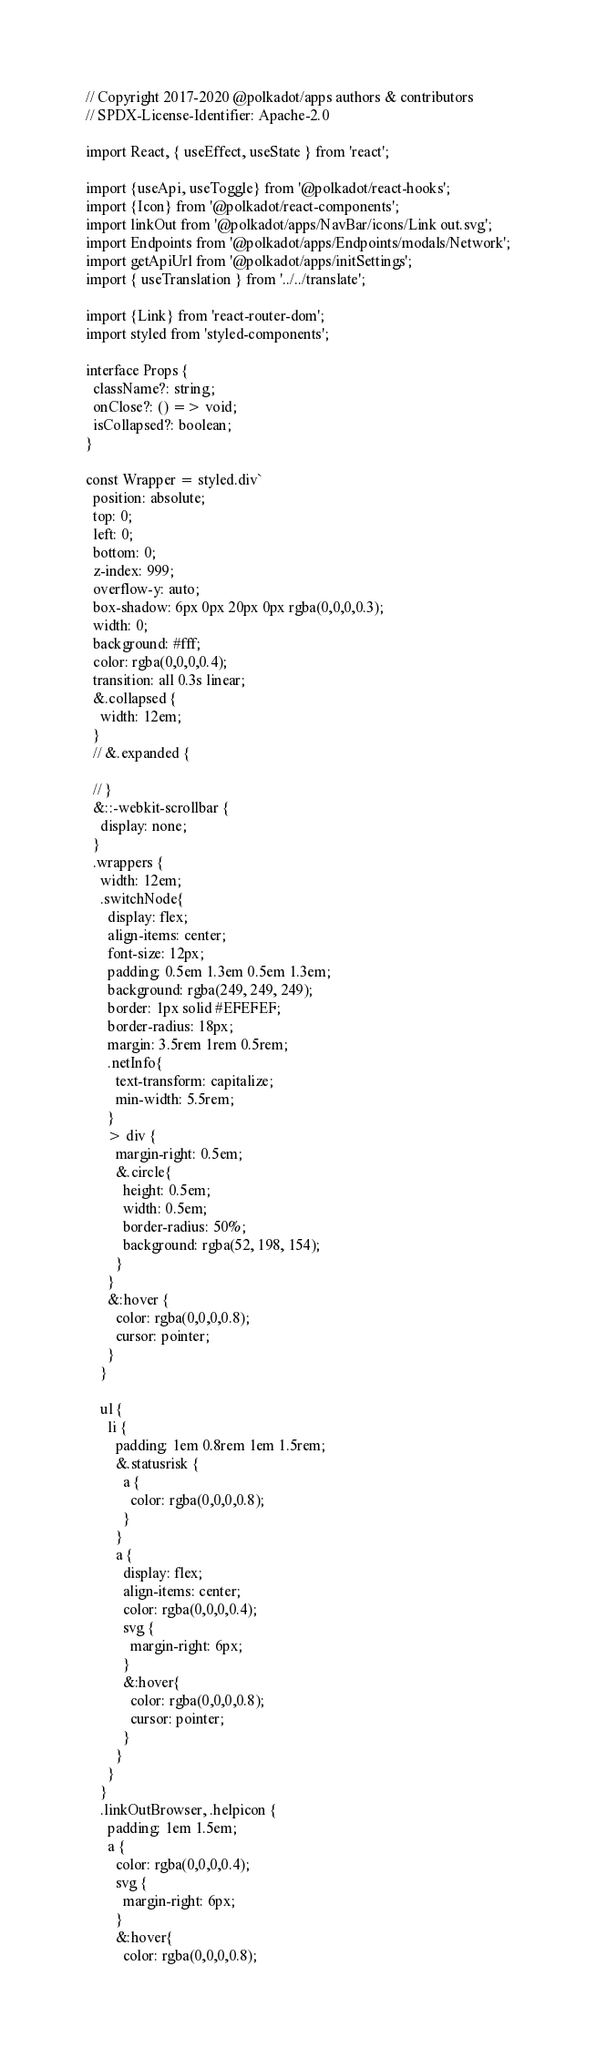Convert code to text. <code><loc_0><loc_0><loc_500><loc_500><_TypeScript_>// Copyright 2017-2020 @polkadot/apps authors & contributors
// SPDX-License-Identifier: Apache-2.0

import React, { useEffect, useState } from 'react';

import {useApi, useToggle} from '@polkadot/react-hooks';
import {Icon} from '@polkadot/react-components';
import linkOut from '@polkadot/apps/NavBar/icons/Link out.svg';
import Endpoints from '@polkadot/apps/Endpoints/modals/Network';
import getApiUrl from '@polkadot/apps/initSettings';
import { useTranslation } from '../../translate';

import {Link} from 'react-router-dom';
import styled from 'styled-components';

interface Props {
  className?: string;
  onClose?: () => void;
  isCollapsed?: boolean;
}

const Wrapper = styled.div`
  position: absolute;
  top: 0;
  left: 0;
  bottom: 0;
  z-index: 999;
  overflow-y: auto;
  box-shadow: 6px 0px 20px 0px rgba(0,0,0,0.3);
  width: 0;
  background: #fff;
  color: rgba(0,0,0,0.4);
  transition: all 0.3s linear;
  &.collapsed {
    width: 12em;
  }
  // &.expanded {

  // }
  &::-webkit-scrollbar {
    display: none;
  }
  .wrappers {
    width: 12em;
    .switchNode{
      display: flex;
      align-items: center;
      font-size: 12px;
      padding: 0.5em 1.3em 0.5em 1.3em;
      background: rgba(249, 249, 249);
      border: 1px solid #EFEFEF;
      border-radius: 18px;
      margin: 3.5rem 1rem 0.5rem;
      .netInfo{
        text-transform: capitalize;
        min-width: 5.5rem;
      }
      > div {
        margin-right: 0.5em;
        &.circle{
          height: 0.5em;
          width: 0.5em;
          border-radius: 50%;
          background: rgba(52, 198, 154);
        }
      }
      &:hover {
        color: rgba(0,0,0,0.8);
        cursor: pointer;
      }
    }

    ul {
      li {
        padding: 1em 0.8rem 1em 1.5rem;
        &.statusrisk {
          a {
            color: rgba(0,0,0,0.8);
          }
        }
        a {
          display: flex;
          align-items: center;
          color: rgba(0,0,0,0.4);
          svg {
            margin-right: 6px;
          }
          &:hover{
            color: rgba(0,0,0,0.8);
            cursor: pointer;
          }
        }
      }
    }
    .linkOutBrowser, .helpicon {
      padding: 1em 1.5em;
      a {
        color: rgba(0,0,0,0.4);
        svg {
          margin-right: 6px;
        }
        &:hover{
          color: rgba(0,0,0,0.8);</code> 